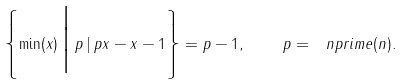<formula> <loc_0><loc_0><loc_500><loc_500>\left \{ \min ( x ) \, \Big | \, p \, | \, p x - x - 1 \right \} = p - 1 , \quad p = \ n p r i m e ( n ) .</formula> 